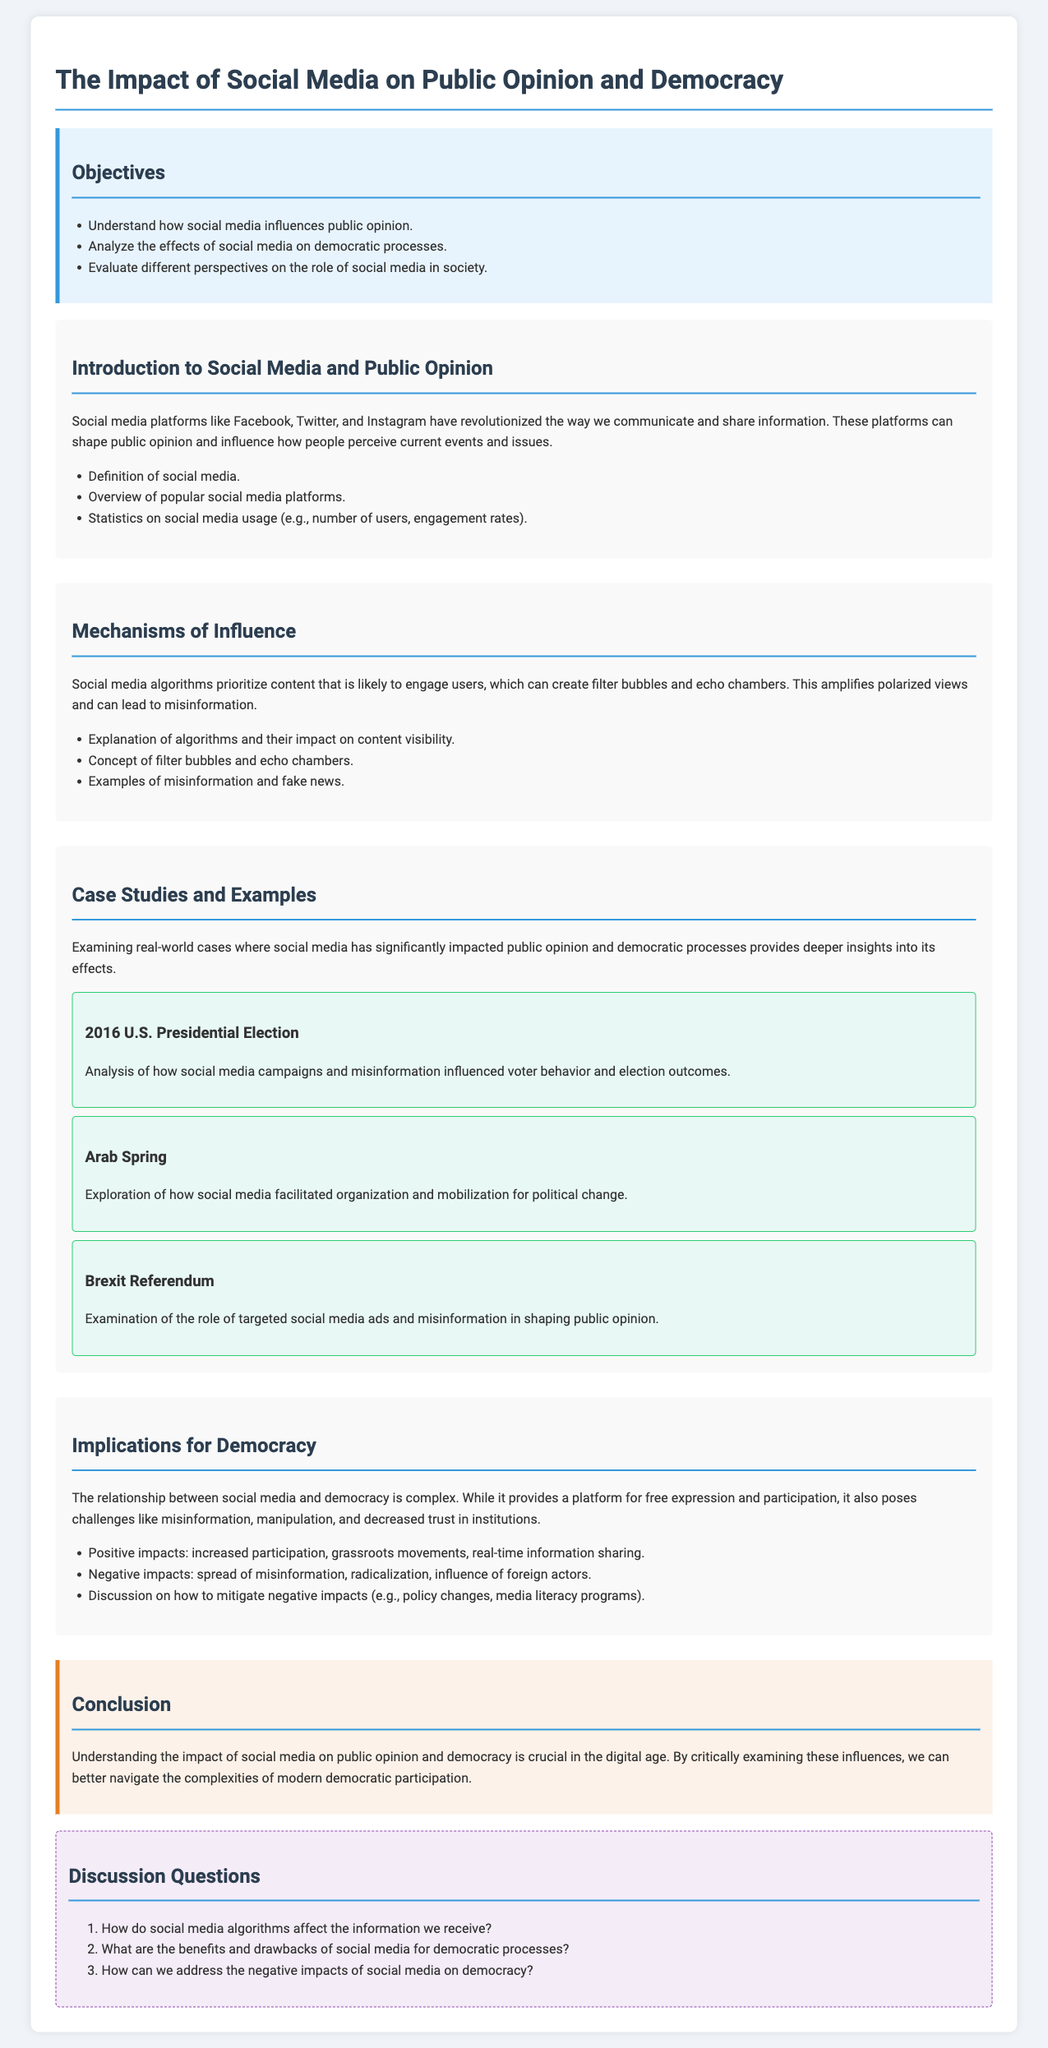What are social media platforms mentioned? The introduction lists specific social media platforms that shape public opinion, which include Facebook, Twitter, and Instagram.
Answer: Facebook, Twitter, Instagram What year was the U.S. Presidential election analyzed? The case study section discusses the impact of social media on the 2016 U.S. Presidential Election, highlighting its relevance during that year.
Answer: 2016 What is one positive impact of social media on democracy? The implications section identifies "increased participation" as a positive aspect of social media's influence on democratic processes.
Answer: Increased participation Name a negative impact of social media discussed. The implications section notes that "spread of misinformation" is a key negative effect that social media has on democracy.
Answer: Spread of misinformation What concept describes the amplified polarized views due to social media? The mechanisms of influence section explains "filter bubbles" and "echo chambers" as terms that describe how social media content visibility can create these phenomena.
Answer: Filter bubbles, echo chambers How many objectives are listed in the lesson plan? The objectives section outlines three distinct goals that guide the lesson's focus and learning outcomes.
Answer: 3 What type of questions are included in the discussion section? The discussion questions section contains open-ended questions meant to provoke thought and conversation about the lessons learned regarding social media.
Answer: Discussion questions What is the overall theme of the conclusion? The conclusion summarizes the importance of understanding social media's impact, emphasizing critical examination in navigating modern democratic participation.
Answer: Understanding the impact of social media 